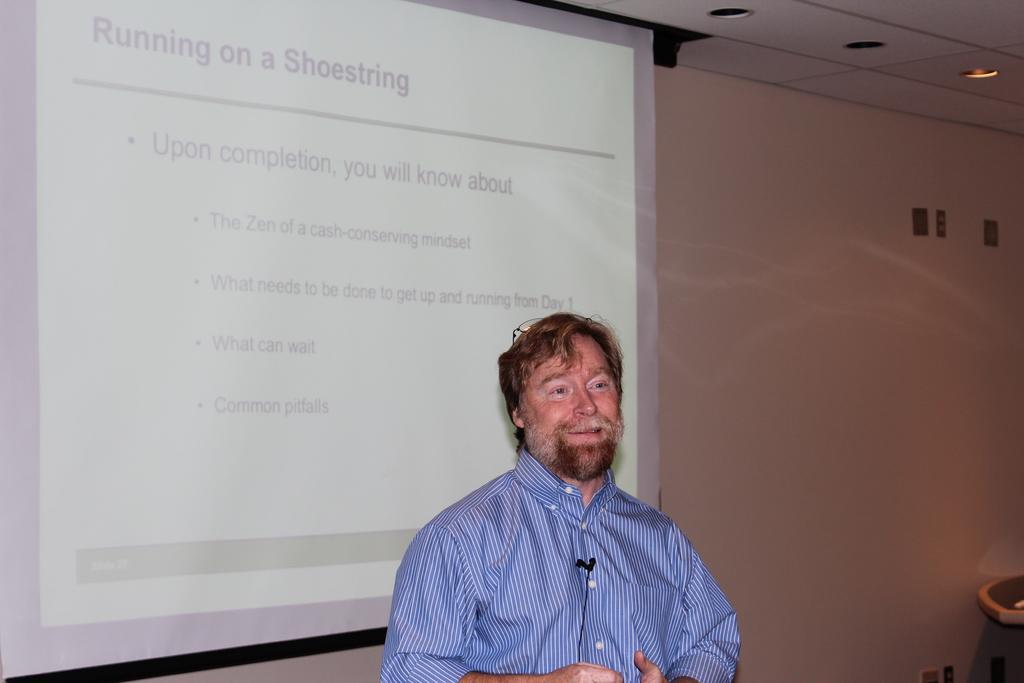Please provide a concise description of this image. In the middle of the image a man is standing. Behind him there is a screen and there is wall. 